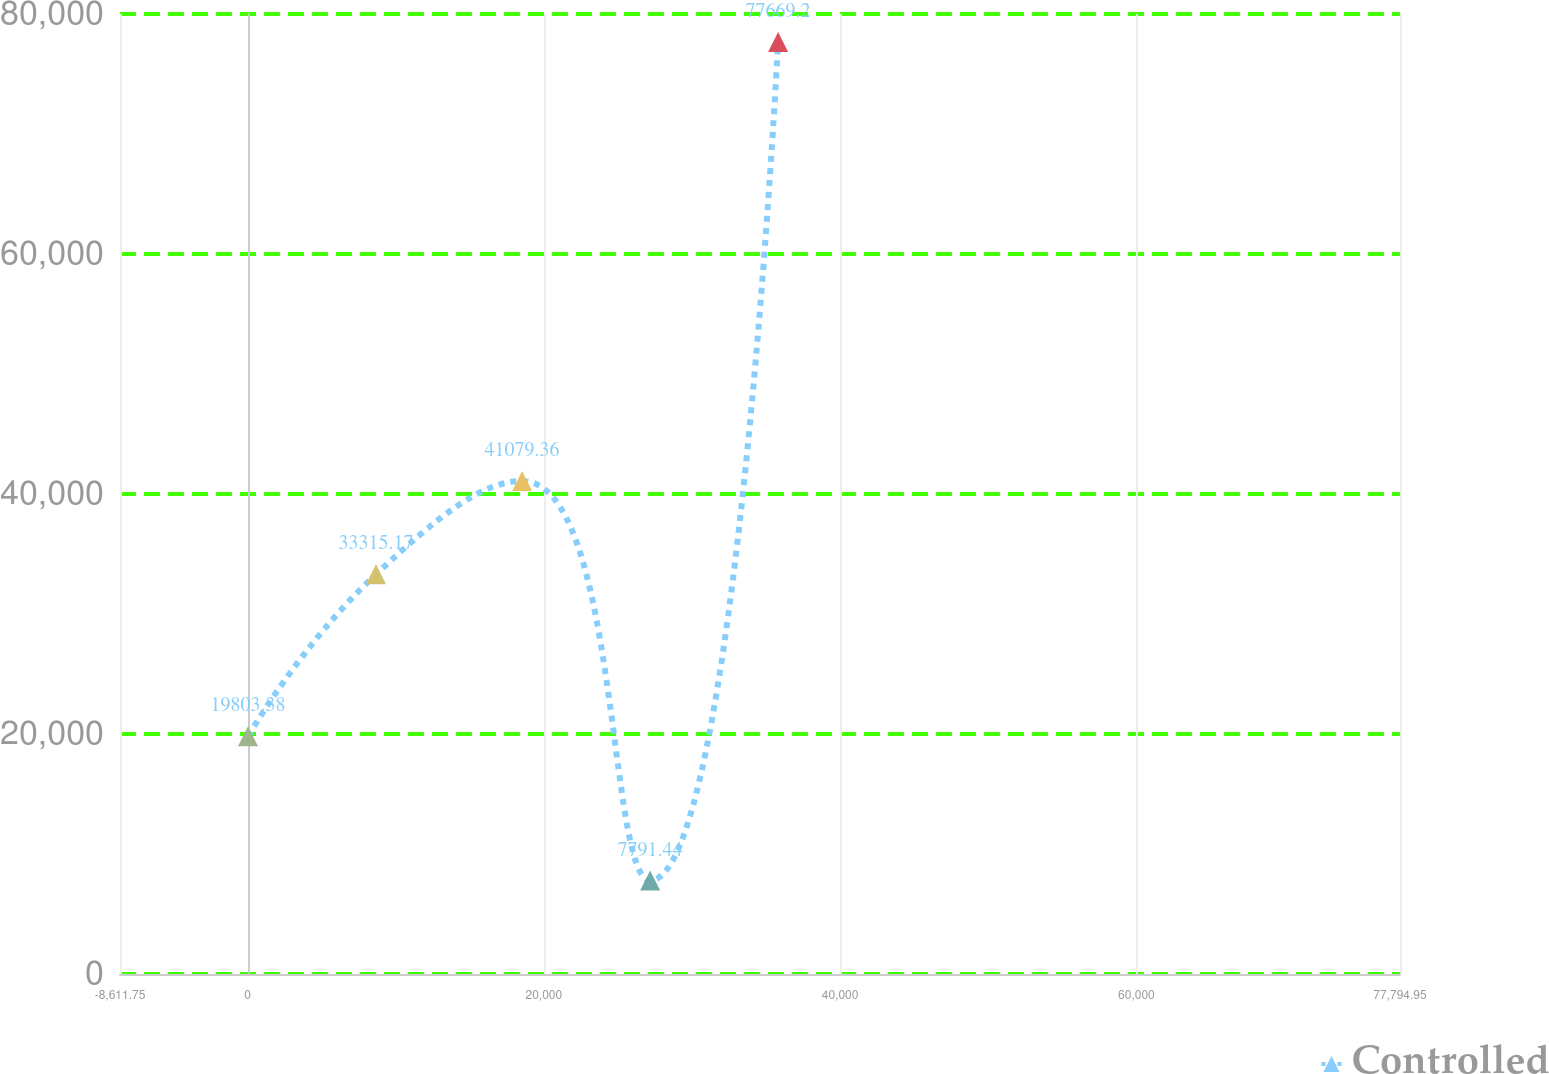Convert chart. <chart><loc_0><loc_0><loc_500><loc_500><line_chart><ecel><fcel>Controlled<nl><fcel>28.92<fcel>19803.4<nl><fcel>8669.59<fcel>33315.2<nl><fcel>18532.1<fcel>41079.4<nl><fcel>27172.8<fcel>7791.44<nl><fcel>35813.4<fcel>77669.2<nl><fcel>86435.6<fcel>27.25<nl></chart> 